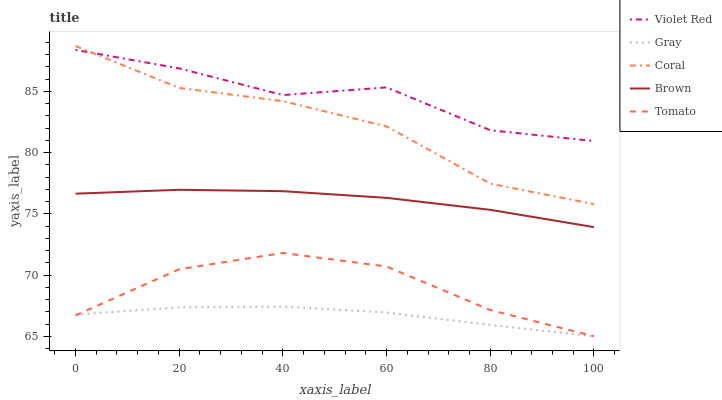Does Violet Red have the minimum area under the curve?
Answer yes or no. No. Does Gray have the maximum area under the curve?
Answer yes or no. No. Is Violet Red the smoothest?
Answer yes or no. No. Is Gray the roughest?
Answer yes or no. No. Does Violet Red have the lowest value?
Answer yes or no. No. Does Violet Red have the highest value?
Answer yes or no. No. Is Tomato less than Coral?
Answer yes or no. Yes. Is Brown greater than Tomato?
Answer yes or no. Yes. Does Tomato intersect Coral?
Answer yes or no. No. 